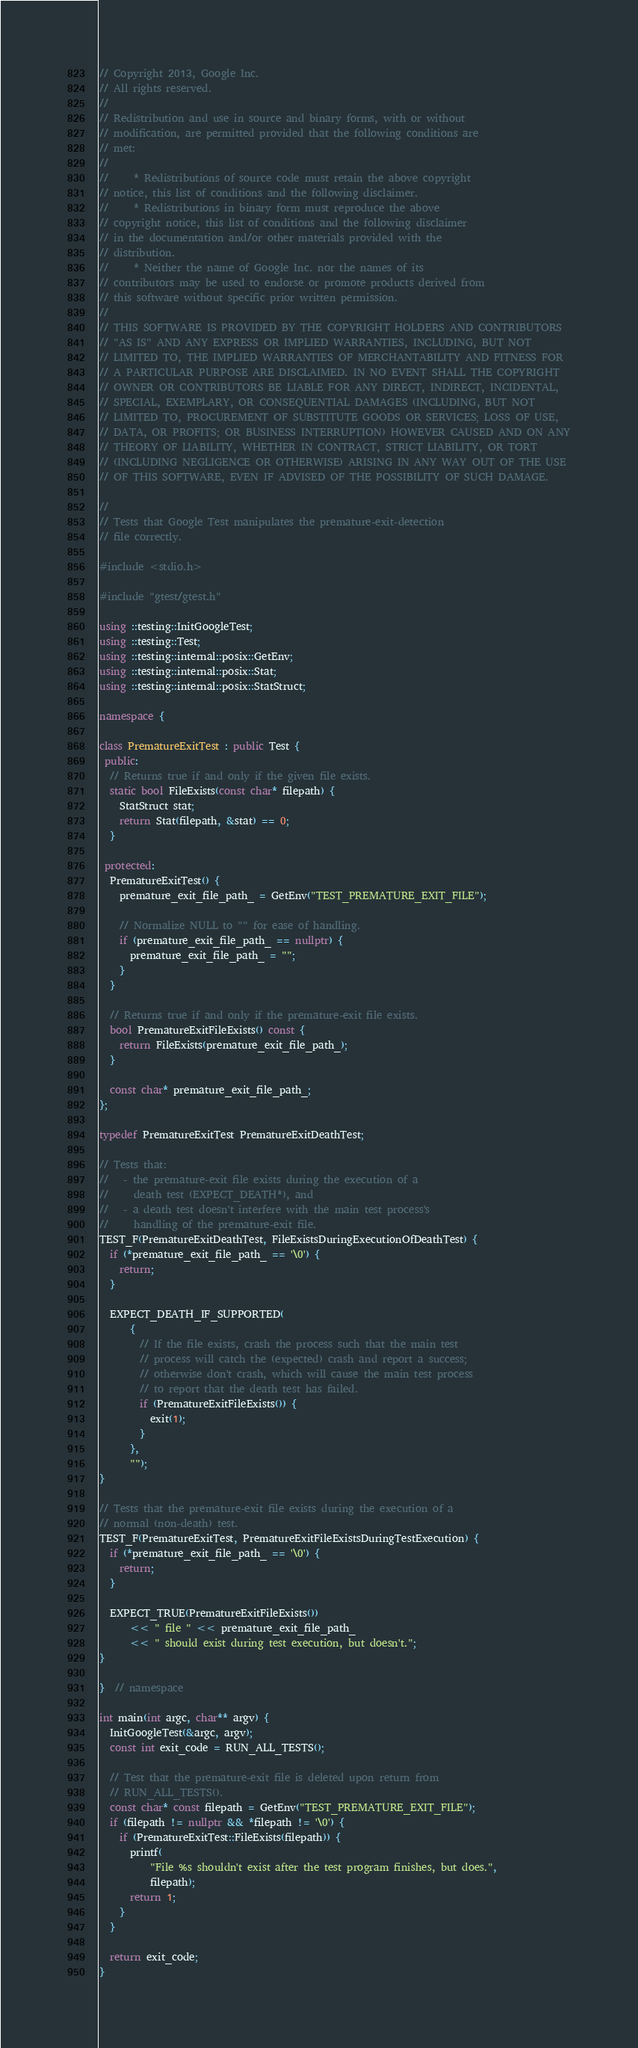<code> <loc_0><loc_0><loc_500><loc_500><_C++_>// Copyright 2013, Google Inc.
// All rights reserved.
//
// Redistribution and use in source and binary forms, with or without
// modification, are permitted provided that the following conditions are
// met:
//
//     * Redistributions of source code must retain the above copyright
// notice, this list of conditions and the following disclaimer.
//     * Redistributions in binary form must reproduce the above
// copyright notice, this list of conditions and the following disclaimer
// in the documentation and/or other materials provided with the
// distribution.
//     * Neither the name of Google Inc. nor the names of its
// contributors may be used to endorse or promote products derived from
// this software without specific prior written permission.
//
// THIS SOFTWARE IS PROVIDED BY THE COPYRIGHT HOLDERS AND CONTRIBUTORS
// "AS IS" AND ANY EXPRESS OR IMPLIED WARRANTIES, INCLUDING, BUT NOT
// LIMITED TO, THE IMPLIED WARRANTIES OF MERCHANTABILITY AND FITNESS FOR
// A PARTICULAR PURPOSE ARE DISCLAIMED. IN NO EVENT SHALL THE COPYRIGHT
// OWNER OR CONTRIBUTORS BE LIABLE FOR ANY DIRECT, INDIRECT, INCIDENTAL,
// SPECIAL, EXEMPLARY, OR CONSEQUENTIAL DAMAGES (INCLUDING, BUT NOT
// LIMITED TO, PROCUREMENT OF SUBSTITUTE GOODS OR SERVICES; LOSS OF USE,
// DATA, OR PROFITS; OR BUSINESS INTERRUPTION) HOWEVER CAUSED AND ON ANY
// THEORY OF LIABILITY, WHETHER IN CONTRACT, STRICT LIABILITY, OR TORT
// (INCLUDING NEGLIGENCE OR OTHERWISE) ARISING IN ANY WAY OUT OF THE USE
// OF THIS SOFTWARE, EVEN IF ADVISED OF THE POSSIBILITY OF SUCH DAMAGE.

//
// Tests that Google Test manipulates the premature-exit-detection
// file correctly.

#include <stdio.h>

#include "gtest/gtest.h"

using ::testing::InitGoogleTest;
using ::testing::Test;
using ::testing::internal::posix::GetEnv;
using ::testing::internal::posix::Stat;
using ::testing::internal::posix::StatStruct;

namespace {

class PrematureExitTest : public Test {
 public:
  // Returns true if and only if the given file exists.
  static bool FileExists(const char* filepath) {
    StatStruct stat;
    return Stat(filepath, &stat) == 0;
  }

 protected:
  PrematureExitTest() {
    premature_exit_file_path_ = GetEnv("TEST_PREMATURE_EXIT_FILE");

    // Normalize NULL to "" for ease of handling.
    if (premature_exit_file_path_ == nullptr) {
      premature_exit_file_path_ = "";
    }
  }

  // Returns true if and only if the premature-exit file exists.
  bool PrematureExitFileExists() const {
    return FileExists(premature_exit_file_path_);
  }

  const char* premature_exit_file_path_;
};

typedef PrematureExitTest PrematureExitDeathTest;

// Tests that:
//   - the premature-exit file exists during the execution of a
//     death test (EXPECT_DEATH*), and
//   - a death test doesn't interfere with the main test process's
//     handling of the premature-exit file.
TEST_F(PrematureExitDeathTest, FileExistsDuringExecutionOfDeathTest) {
  if (*premature_exit_file_path_ == '\0') {
    return;
  }

  EXPECT_DEATH_IF_SUPPORTED(
      {
        // If the file exists, crash the process such that the main test
        // process will catch the (expected) crash and report a success;
        // otherwise don't crash, which will cause the main test process
        // to report that the death test has failed.
        if (PrematureExitFileExists()) {
          exit(1);
        }
      },
      "");
}

// Tests that the premature-exit file exists during the execution of a
// normal (non-death) test.
TEST_F(PrematureExitTest, PrematureExitFileExistsDuringTestExecution) {
  if (*premature_exit_file_path_ == '\0') {
    return;
  }

  EXPECT_TRUE(PrematureExitFileExists())
      << " file " << premature_exit_file_path_
      << " should exist during test execution, but doesn't.";
}

}  // namespace

int main(int argc, char** argv) {
  InitGoogleTest(&argc, argv);
  const int exit_code = RUN_ALL_TESTS();

  // Test that the premature-exit file is deleted upon return from
  // RUN_ALL_TESTS().
  const char* const filepath = GetEnv("TEST_PREMATURE_EXIT_FILE");
  if (filepath != nullptr && *filepath != '\0') {
    if (PrematureExitTest::FileExists(filepath)) {
      printf(
          "File %s shouldn't exist after the test program finishes, but does.",
          filepath);
      return 1;
    }
  }

  return exit_code;
}
</code> 